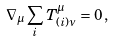Convert formula to latex. <formula><loc_0><loc_0><loc_500><loc_500>\nabla _ { \mu } \sum _ { i } T ^ { \mu } _ { ( i ) \nu } = 0 \, ,</formula> 